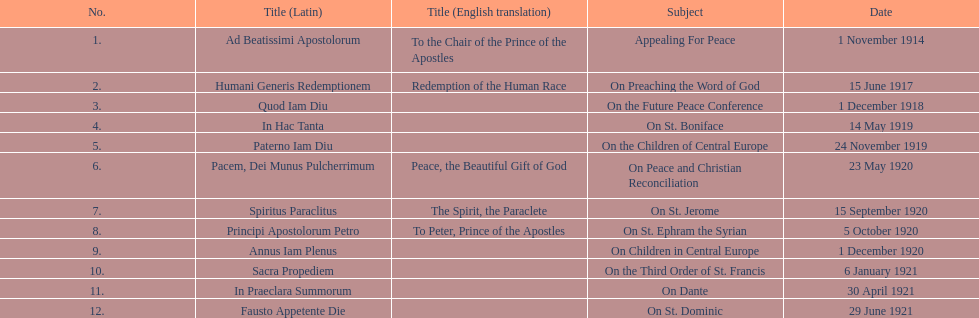How many titles did not list an english translation? 7. Can you parse all the data within this table? {'header': ['No.', 'Title (Latin)', 'Title (English translation)', 'Subject', 'Date'], 'rows': [['1.', 'Ad Beatissimi Apostolorum', 'To the Chair of the Prince of the Apostles', 'Appealing For Peace', '1 November 1914'], ['2.', 'Humani Generis Redemptionem', 'Redemption of the Human Race', 'On Preaching the Word of God', '15 June 1917'], ['3.', 'Quod Iam Diu', '', 'On the Future Peace Conference', '1 December 1918'], ['4.', 'In Hac Tanta', '', 'On St. Boniface', '14 May 1919'], ['5.', 'Paterno Iam Diu', '', 'On the Children of Central Europe', '24 November 1919'], ['6.', 'Pacem, Dei Munus Pulcherrimum', 'Peace, the Beautiful Gift of God', 'On Peace and Christian Reconciliation', '23 May 1920'], ['7.', 'Spiritus Paraclitus', 'The Spirit, the Paraclete', 'On St. Jerome', '15 September 1920'], ['8.', 'Principi Apostolorum Petro', 'To Peter, Prince of the Apostles', 'On St. Ephram the Syrian', '5 October 1920'], ['9.', 'Annus Iam Plenus', '', 'On Children in Central Europe', '1 December 1920'], ['10.', 'Sacra Propediem', '', 'On the Third Order of St. Francis', '6 January 1921'], ['11.', 'In Praeclara Summorum', '', 'On Dante', '30 April 1921'], ['12.', 'Fausto Appetente Die', '', 'On St. Dominic', '29 June 1921']]} 